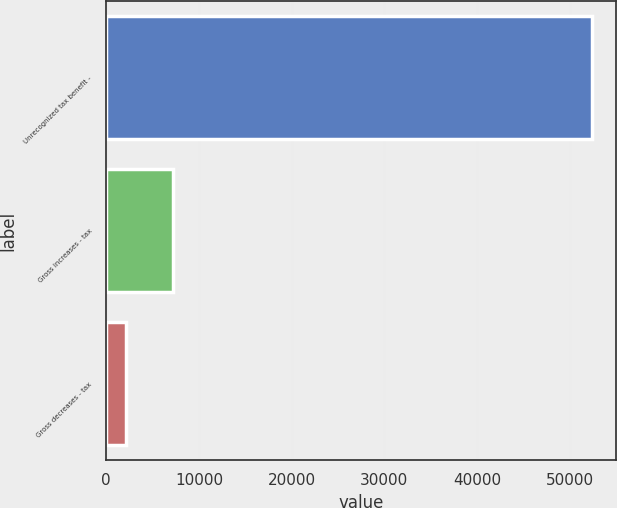Convert chart to OTSL. <chart><loc_0><loc_0><loc_500><loc_500><bar_chart><fcel>Unrecognized tax benefit -<fcel>Gross increases - tax<fcel>Gross decreases - tax<nl><fcel>52356<fcel>7183.2<fcel>2164<nl></chart> 